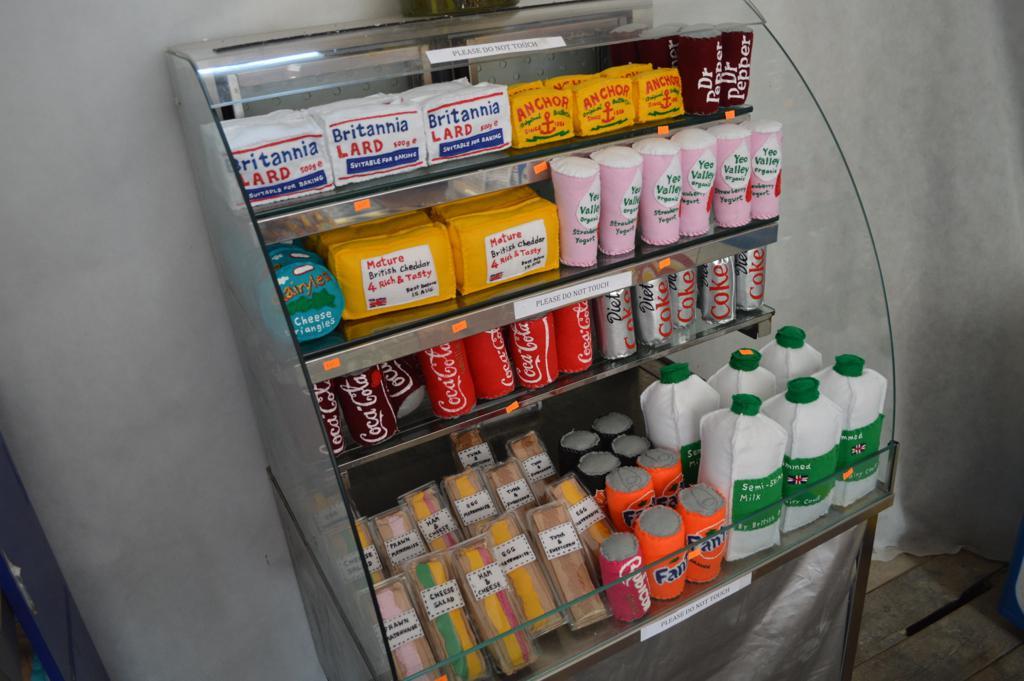Who makes that lard?
Your response must be concise. Britannia. What is the name of the soda?
Make the answer very short. Coca cola. 